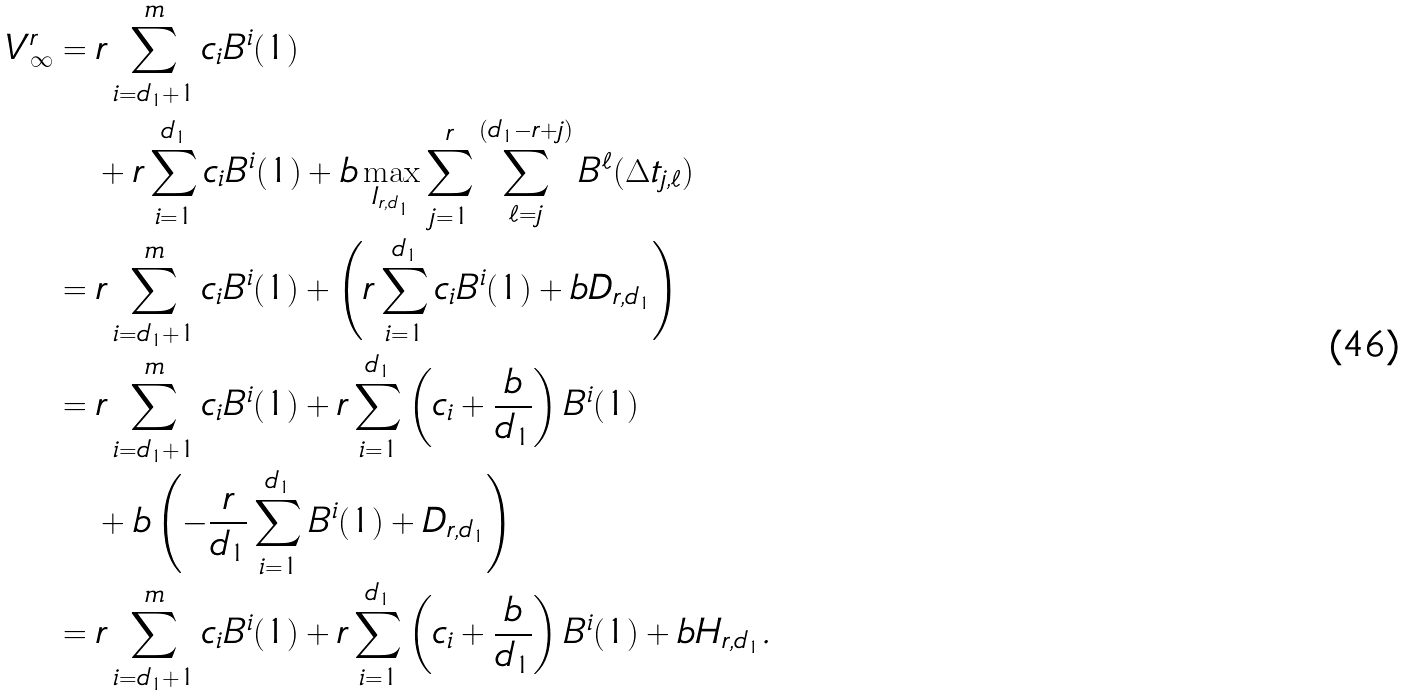Convert formula to latex. <formula><loc_0><loc_0><loc_500><loc_500>V ^ { r } _ { \infty } & = r \sum _ { i = d _ { 1 } + 1 } ^ { m } c _ { i } B ^ { i } ( 1 ) \\ & \quad + r \sum _ { i = 1 } ^ { d _ { 1 } } c _ { i } B ^ { i } ( 1 ) + b \max _ { I _ { r , d _ { 1 } } } \sum _ { j = 1 } ^ { r } \sum _ { \ell = j } ^ { ( d _ { 1 } - r + j ) } B ^ { \ell } ( \Delta t _ { j , \ell } ) \\ & = r \sum _ { i = d _ { 1 } + 1 } ^ { m } c _ { i } B ^ { i } ( 1 ) + \left ( r \sum _ { i = 1 } ^ { d _ { 1 } } c _ { i } B ^ { i } ( 1 ) + b D _ { r , d _ { 1 } } \right ) \\ & = r \sum _ { i = d _ { 1 } + 1 } ^ { m } c _ { i } B ^ { i } ( 1 ) + r \sum _ { i = 1 } ^ { d _ { 1 } } \left ( c _ { i } + \frac { b } { d _ { 1 } } \right ) B ^ { i } ( 1 ) \\ & \quad + b \left ( - \frac { r } { d _ { 1 } } \sum _ { i = 1 } ^ { d _ { 1 } } B ^ { i } ( 1 ) + D _ { r , d _ { 1 } } \right ) \\ & = r \sum _ { i = d _ { 1 } + 1 } ^ { m } c _ { i } B ^ { i } ( 1 ) + r \sum _ { i = 1 } ^ { d _ { 1 } } \left ( c _ { i } + \frac { b } { d _ { 1 } } \right ) B ^ { i } ( 1 ) + b H _ { r , d _ { 1 } } .</formula> 